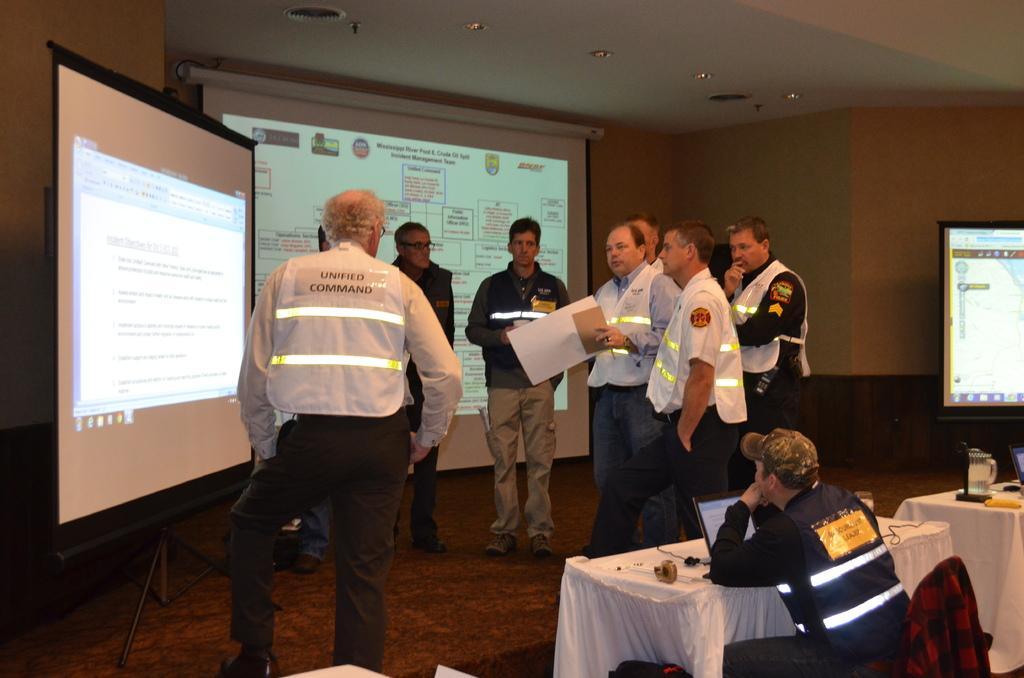Please provide a concise description of this image. In this picture we can see a person holding a paper in his hand. There are few people standing on the path. We can see projectors from left to right. There is a man sitting on a chair. We can see a jacket on this chair. There is a laptop and a few devices on the table. We can see a jug, laptop and a yellow object on another table. Some lights are visible on top. 